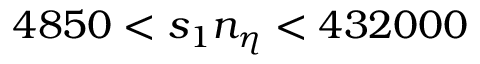<formula> <loc_0><loc_0><loc_500><loc_500>4 8 5 0 < s _ { 1 } n _ { \eta } < 4 3 2 0 0 0</formula> 